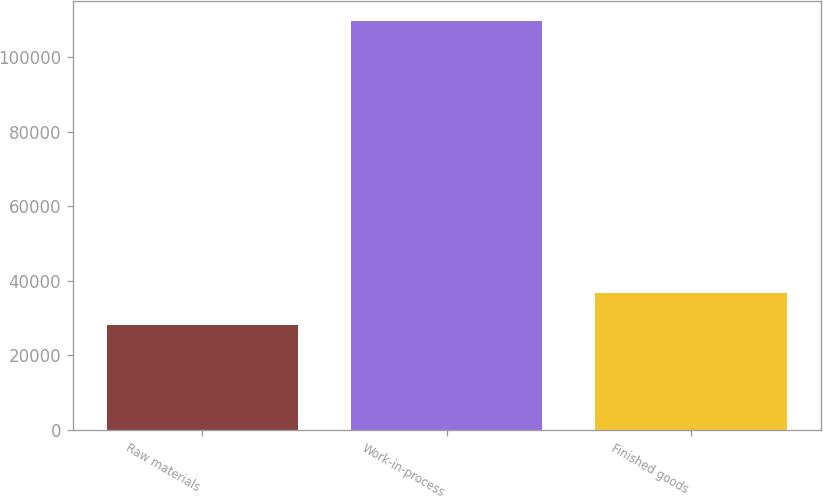<chart> <loc_0><loc_0><loc_500><loc_500><bar_chart><fcel>Raw materials<fcel>Work-in-process<fcel>Finished goods<nl><fcel>28138<fcel>109653<fcel>36781<nl></chart> 